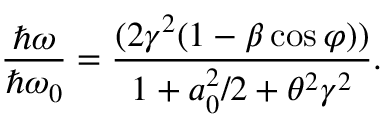<formula> <loc_0><loc_0><loc_500><loc_500>\frac { \hbar { \omega } } { \hbar { \omega } _ { 0 } } = \frac { ( 2 \gamma ^ { 2 } ( 1 - \beta \cos \varphi ) ) } { 1 + a _ { 0 } ^ { 2 } / 2 + \theta ^ { 2 } \gamma ^ { 2 } } .</formula> 